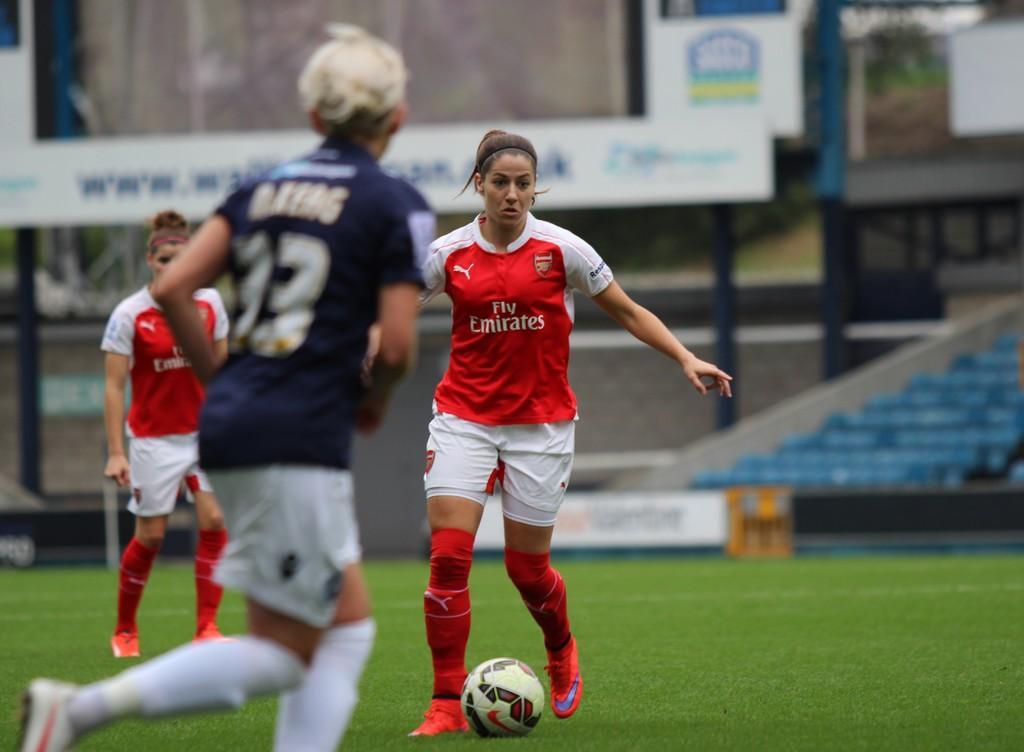Can you describe this image briefly? This image is taken in the stadium. In this image we can see there are three players playing with a ball in the playground. 